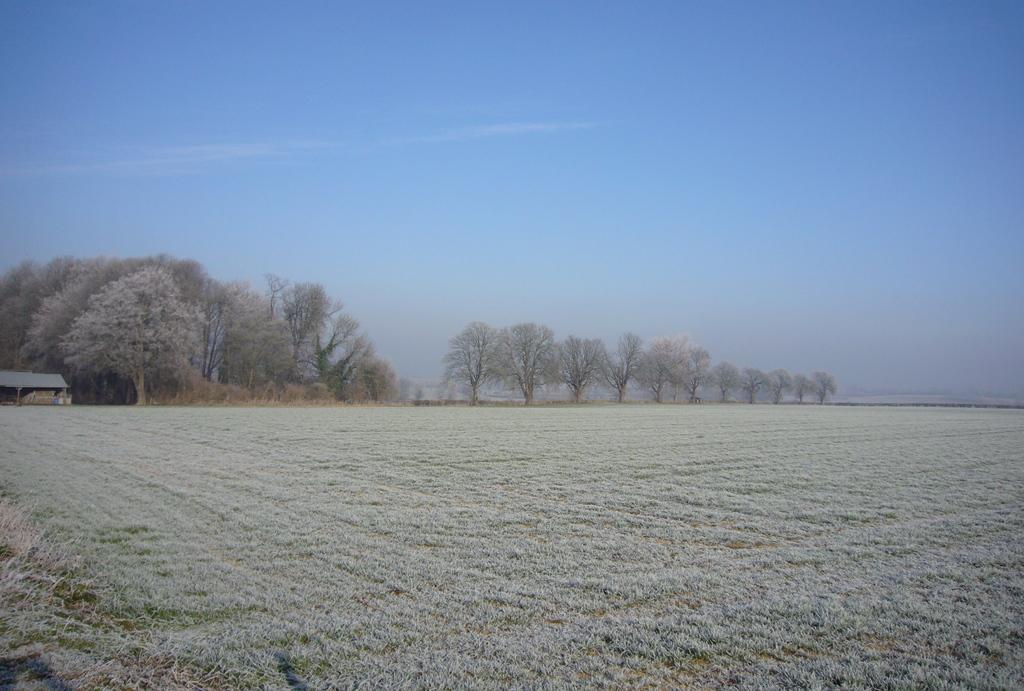What is located in the middle of the image? There are trees in the middle of the image. What is visible at the top of the image? The sky is visible at the top of the image. What is the color of the sky in the image? The color of the sky is blue. Can you tell me how many spies are hiding in the bushes in the image? There are no spies or bushes present in the image; it features trees and a blue sky. What type of wine is being served in the image? There is no wine present in the image. 